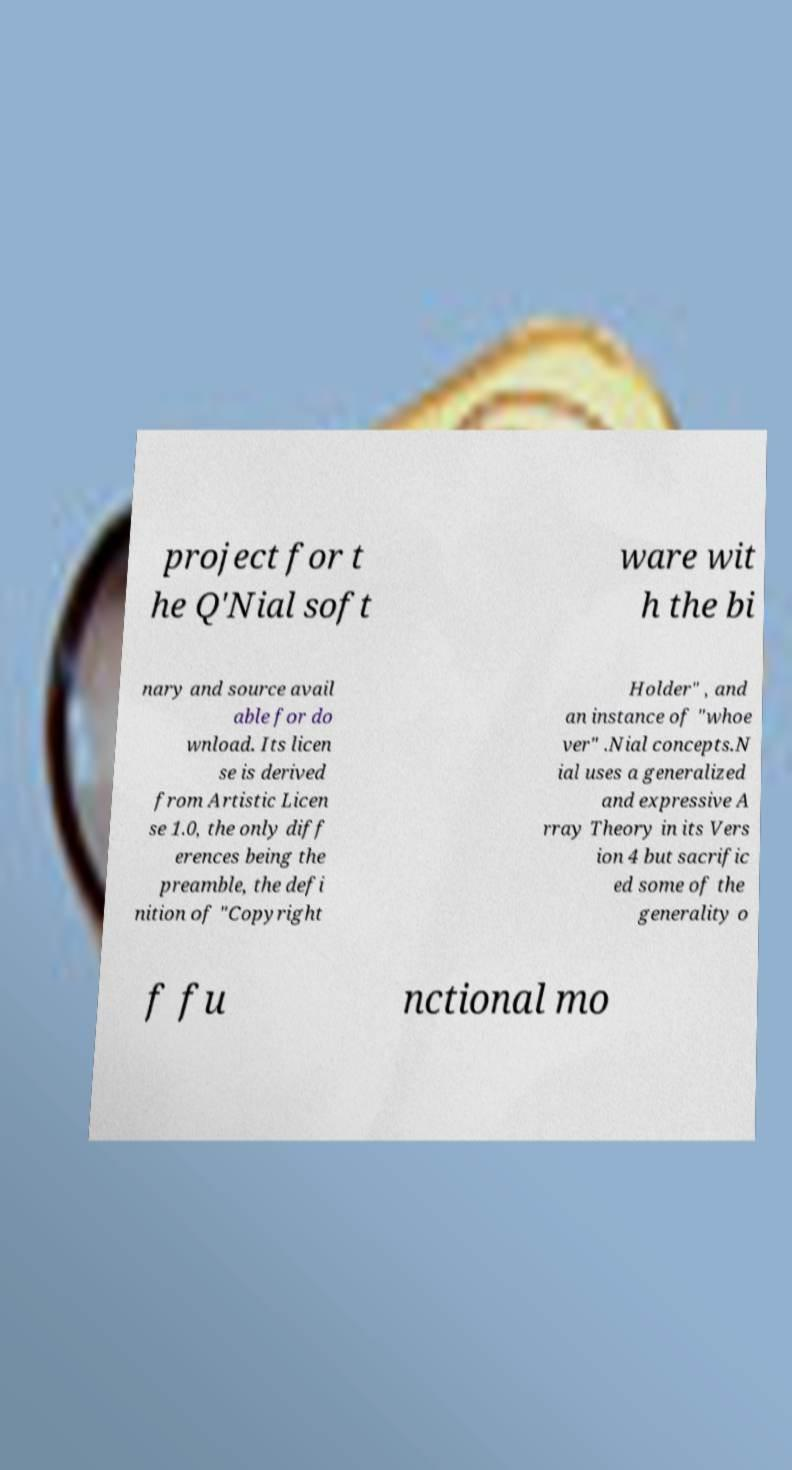What messages or text are displayed in this image? I need them in a readable, typed format. project for t he Q'Nial soft ware wit h the bi nary and source avail able for do wnload. Its licen se is derived from Artistic Licen se 1.0, the only diff erences being the preamble, the defi nition of "Copyright Holder" , and an instance of "whoe ver" .Nial concepts.N ial uses a generalized and expressive A rray Theory in its Vers ion 4 but sacrific ed some of the generality o f fu nctional mo 